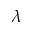<formula> <loc_0><loc_0><loc_500><loc_500>\lambda</formula> 